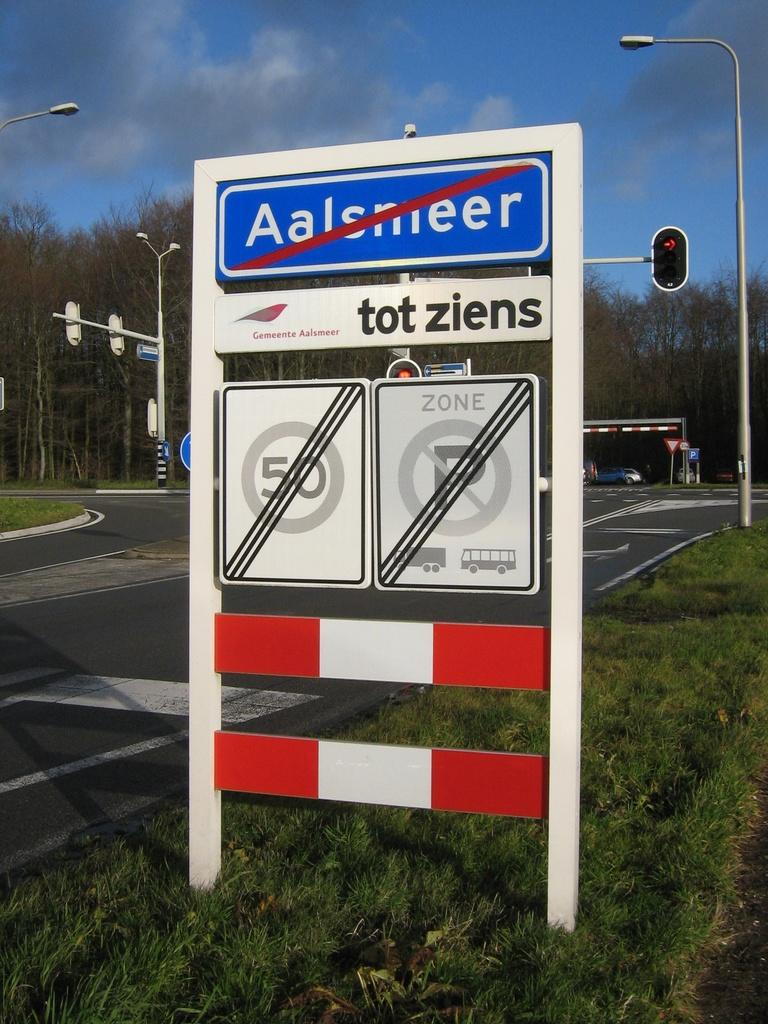<image>
Offer a succinct explanation of the picture presented. A blue sign that reads Aalsmeer has a red cross through it 